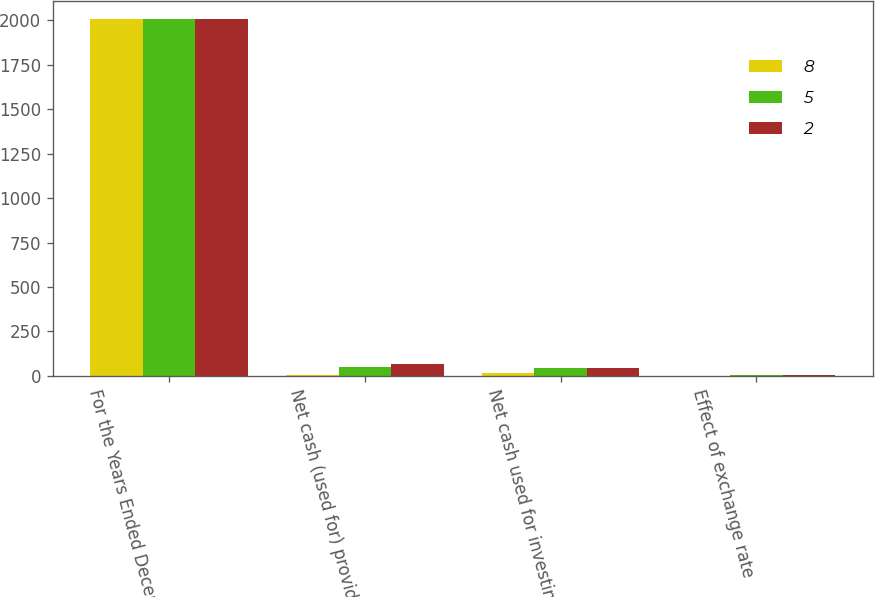<chart> <loc_0><loc_0><loc_500><loc_500><stacked_bar_chart><ecel><fcel>For the Years Ended December<fcel>Net cash (used for) provided<fcel>Net cash used for investing<fcel>Effect of exchange rate<nl><fcel>8<fcel>2010<fcel>6<fcel>14<fcel>2<nl><fcel>5<fcel>2009<fcel>50<fcel>42<fcel>5<nl><fcel>2<fcel>2008<fcel>69<fcel>47<fcel>8<nl></chart> 